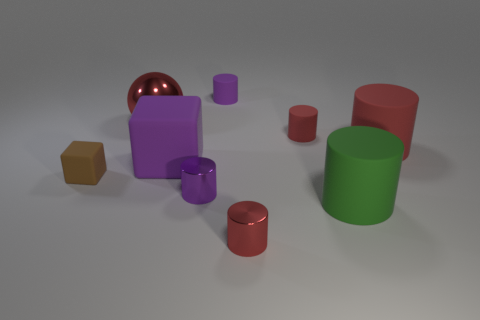There is a small matte object that is both on the right side of the large red metallic thing and in front of the big metal ball; what color is it?
Your response must be concise. Red. There is a matte thing in front of the small purple shiny object; is there a small rubber object right of it?
Your response must be concise. No. Is the number of big purple objects left of the brown cube the same as the number of big blue cylinders?
Make the answer very short. Yes. There is a object on the left side of the big thing left of the large purple thing; what number of blocks are on the right side of it?
Provide a succinct answer. 1. Is there a purple shiny object of the same size as the green rubber thing?
Give a very brief answer. No. Is the number of tiny rubber cylinders right of the purple metal object less than the number of big gray shiny cubes?
Provide a succinct answer. No. What is the material of the brown cube that is behind the tiny shiny thing that is to the right of the small object behind the metallic ball?
Your response must be concise. Rubber. Is the number of rubber blocks to the left of the small brown matte thing greater than the number of purple cylinders behind the big red rubber cylinder?
Provide a short and direct response. No. How many matte things are either tiny red balls or red things?
Provide a succinct answer. 2. There is a metallic thing that is the same color as the big shiny sphere; what shape is it?
Offer a very short reply. Cylinder. 